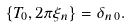Convert formula to latex. <formula><loc_0><loc_0><loc_500><loc_500>\{ T _ { 0 } , 2 \pi \xi _ { n } \} = \delta _ { n \, 0 } .</formula> 